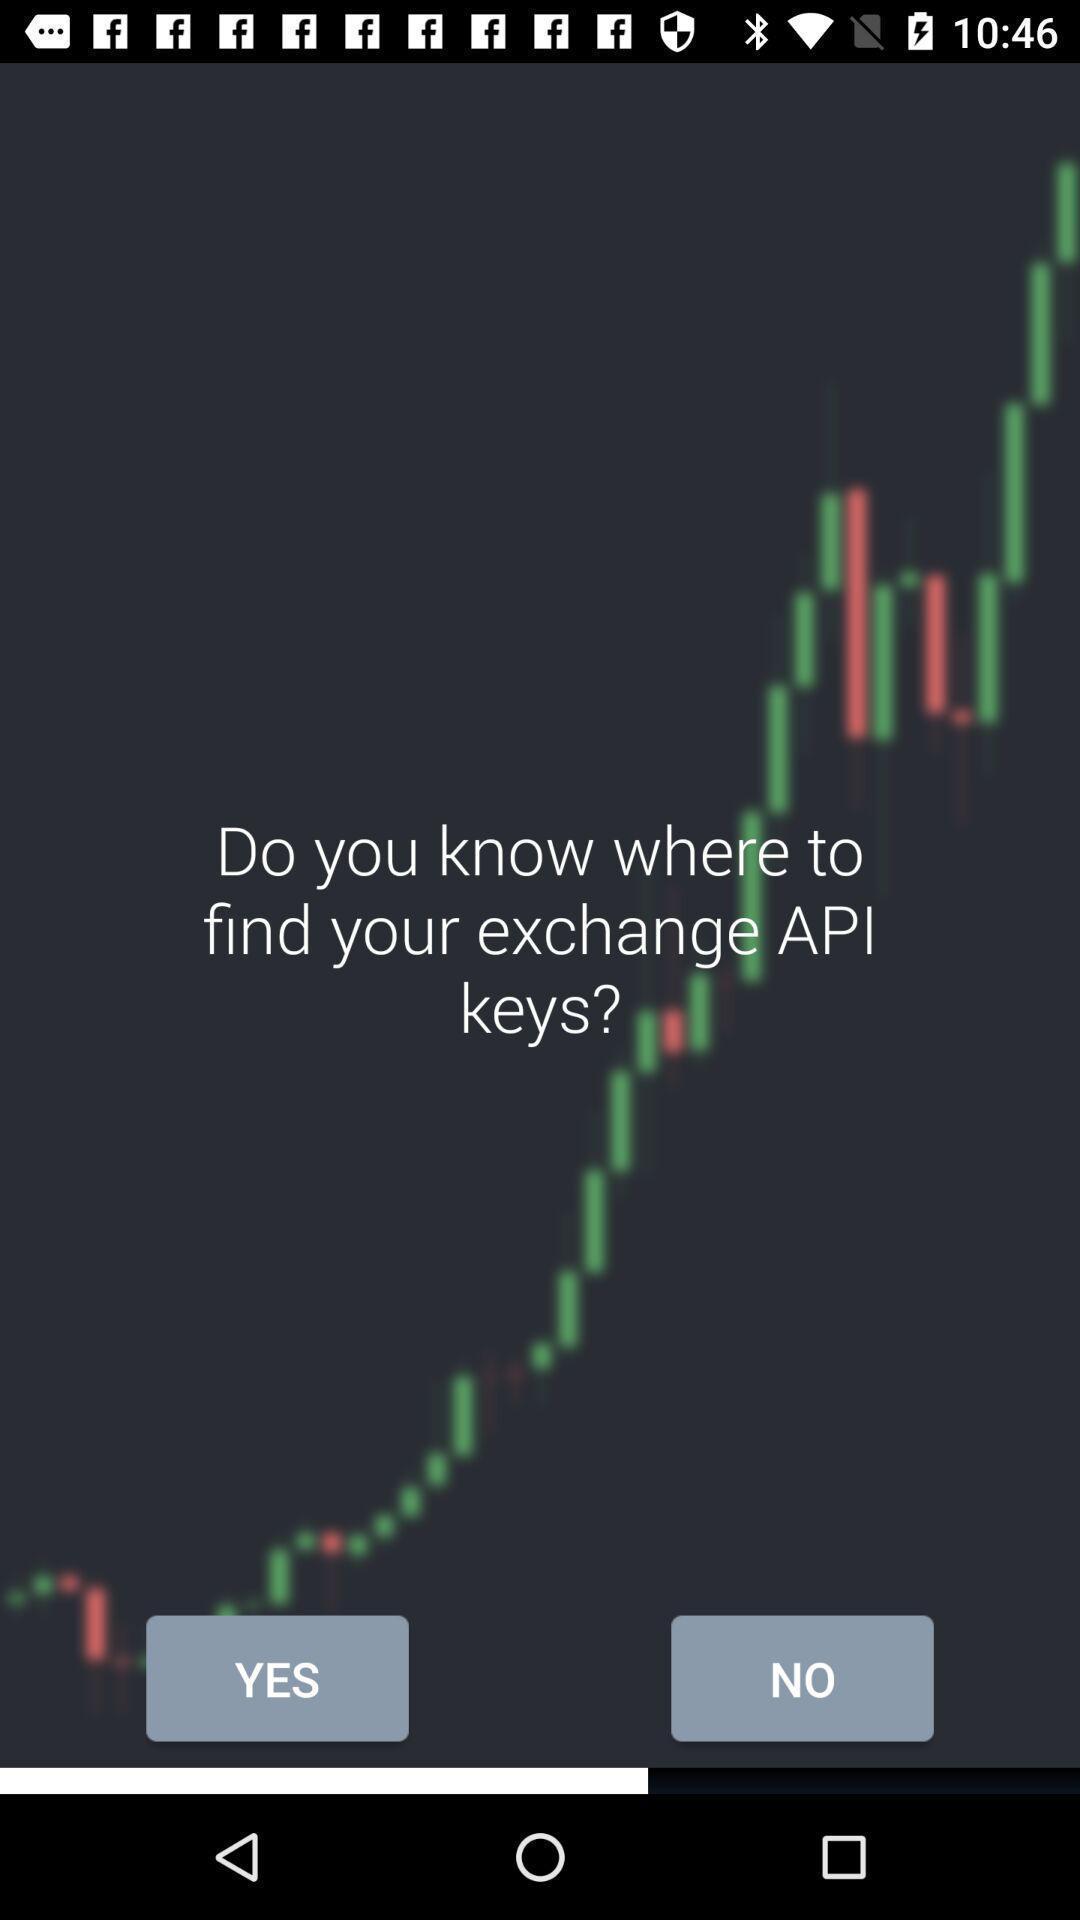Describe the content in this image. Screen page displaying yes and no options. 